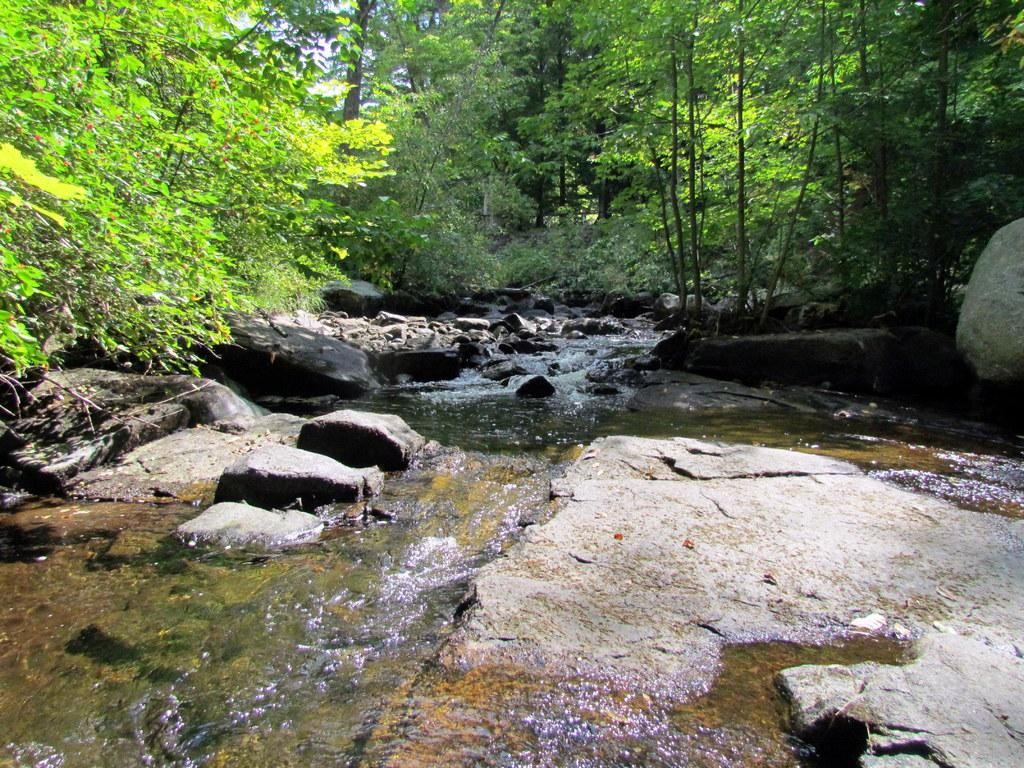What is the primary element visible in the image? There is water in the image. What can be seen near the water? There are many rocks near the water. What type of vegetation is visible in the background of the image? There are many trees in the background of the image. What is visible in the sky in the image? The sky is visible in the background of the image. Are there any dinosaurs visible in the image? No, there are no dinosaurs present in the image. What type of discovery can be made near the water in the image? There is no specific discovery mentioned or depicted in the image; it simply shows water, rocks, trees, and the sky. 